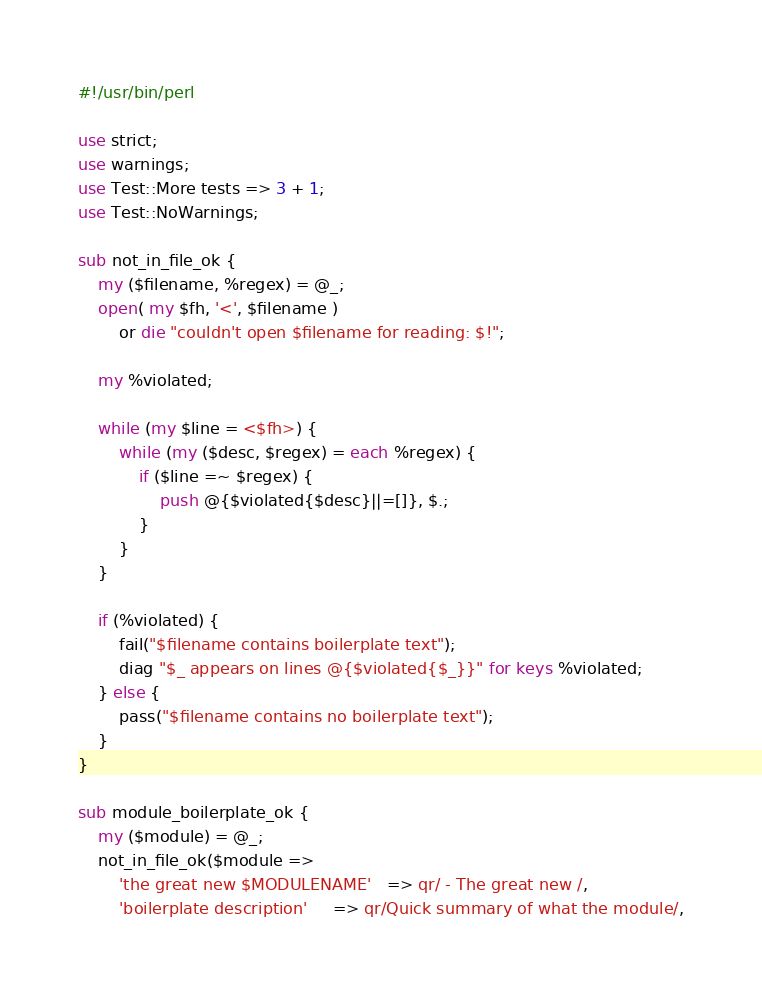<code> <loc_0><loc_0><loc_500><loc_500><_Perl_>#!/usr/bin/perl

use strict;
use warnings;
use Test::More tests => 3 + 1;
use Test::NoWarnings;

sub not_in_file_ok {
    my ($filename, %regex) = @_;
    open( my $fh, '<', $filename )
        or die "couldn't open $filename for reading: $!";

    my %violated;

    while (my $line = <$fh>) {
        while (my ($desc, $regex) = each %regex) {
            if ($line =~ $regex) {
                push @{$violated{$desc}||=[]}, $.;
            }
        }
    }

    if (%violated) {
        fail("$filename contains boilerplate text");
        diag "$_ appears on lines @{$violated{$_}}" for keys %violated;
    } else {
        pass("$filename contains no boilerplate text");
    }
}

sub module_boilerplate_ok {
    my ($module) = @_;
    not_in_file_ok($module =>
        'the great new $MODULENAME'   => qr/ - The great new /,
        'boilerplate description'     => qr/Quick summary of what the module/,</code> 